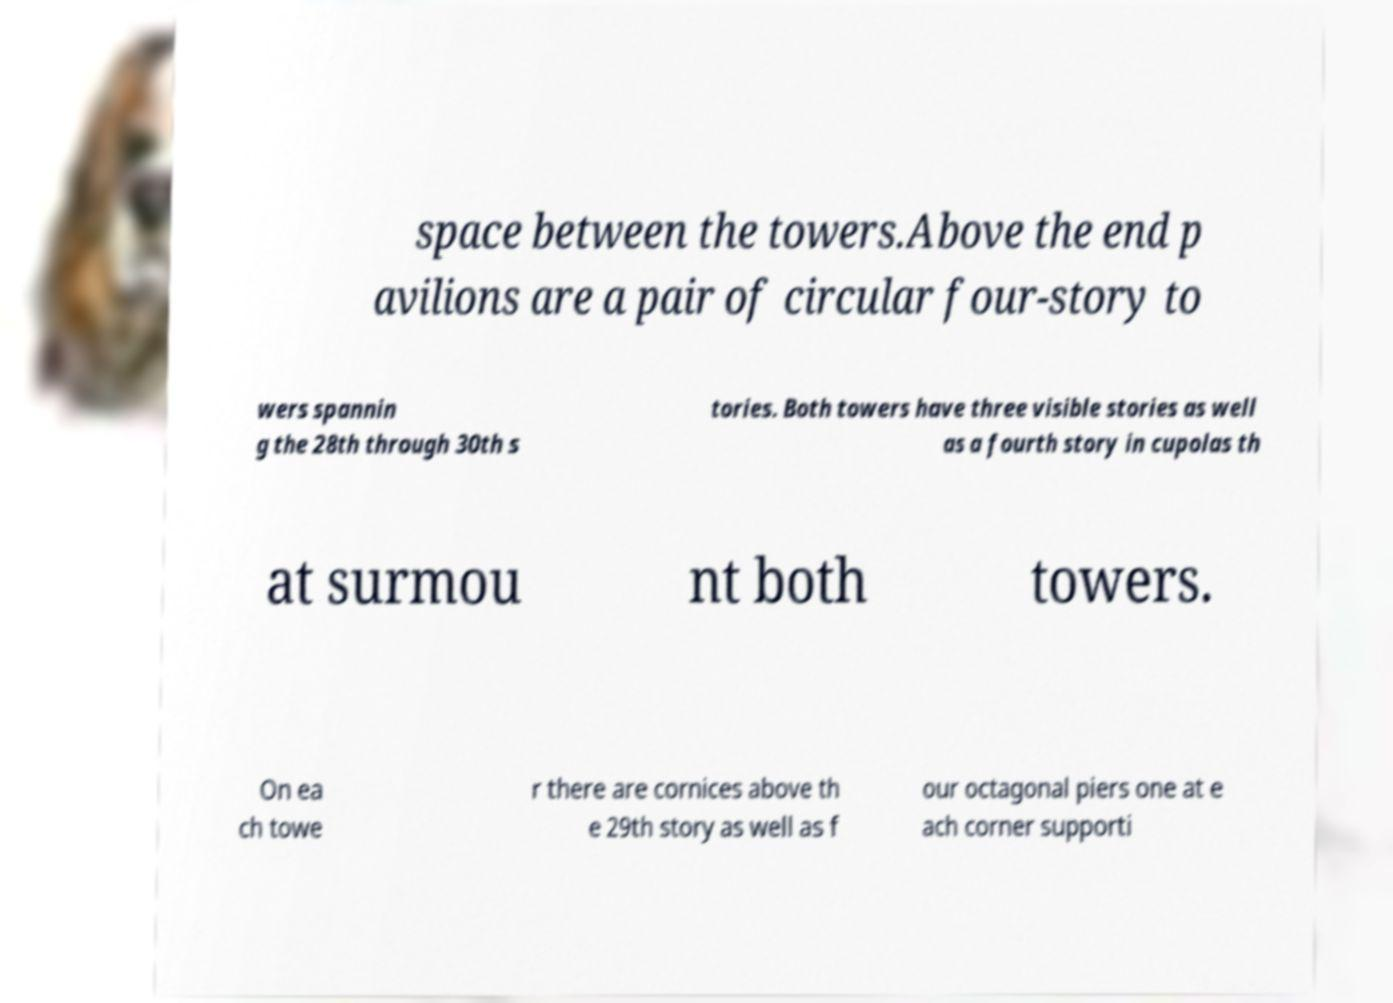Could you extract and type out the text from this image? space between the towers.Above the end p avilions are a pair of circular four-story to wers spannin g the 28th through 30th s tories. Both towers have three visible stories as well as a fourth story in cupolas th at surmou nt both towers. On ea ch towe r there are cornices above th e 29th story as well as f our octagonal piers one at e ach corner supporti 